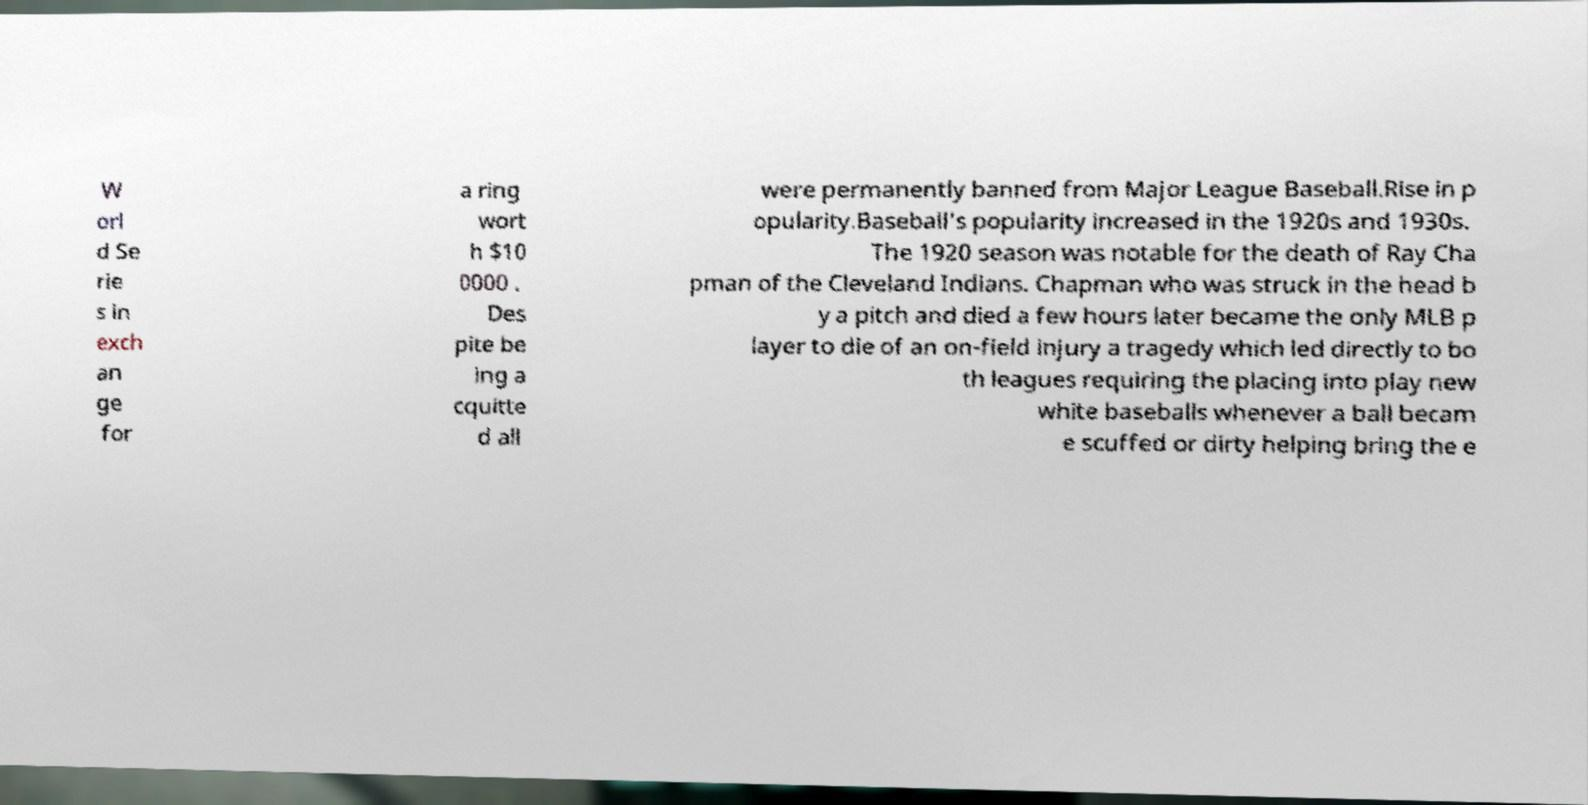For documentation purposes, I need the text within this image transcribed. Could you provide that? W orl d Se rie s in exch an ge for a ring wort h $10 0000 . Des pite be ing a cquitte d all were permanently banned from Major League Baseball.Rise in p opularity.Baseball's popularity increased in the 1920s and 1930s. The 1920 season was notable for the death of Ray Cha pman of the Cleveland Indians. Chapman who was struck in the head b y a pitch and died a few hours later became the only MLB p layer to die of an on-field injury a tragedy which led directly to bo th leagues requiring the placing into play new white baseballs whenever a ball becam e scuffed or dirty helping bring the e 